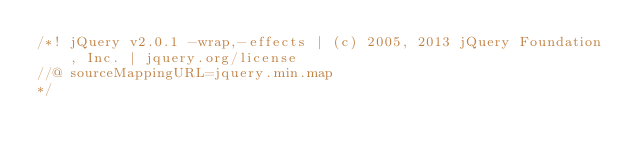<code> <loc_0><loc_0><loc_500><loc_500><_JavaScript_>/*! jQuery v2.0.1 -wrap,-effects | (c) 2005, 2013 jQuery Foundation, Inc. | jquery.org/license
//@ sourceMappingURL=jquery.min.map
*/</code> 